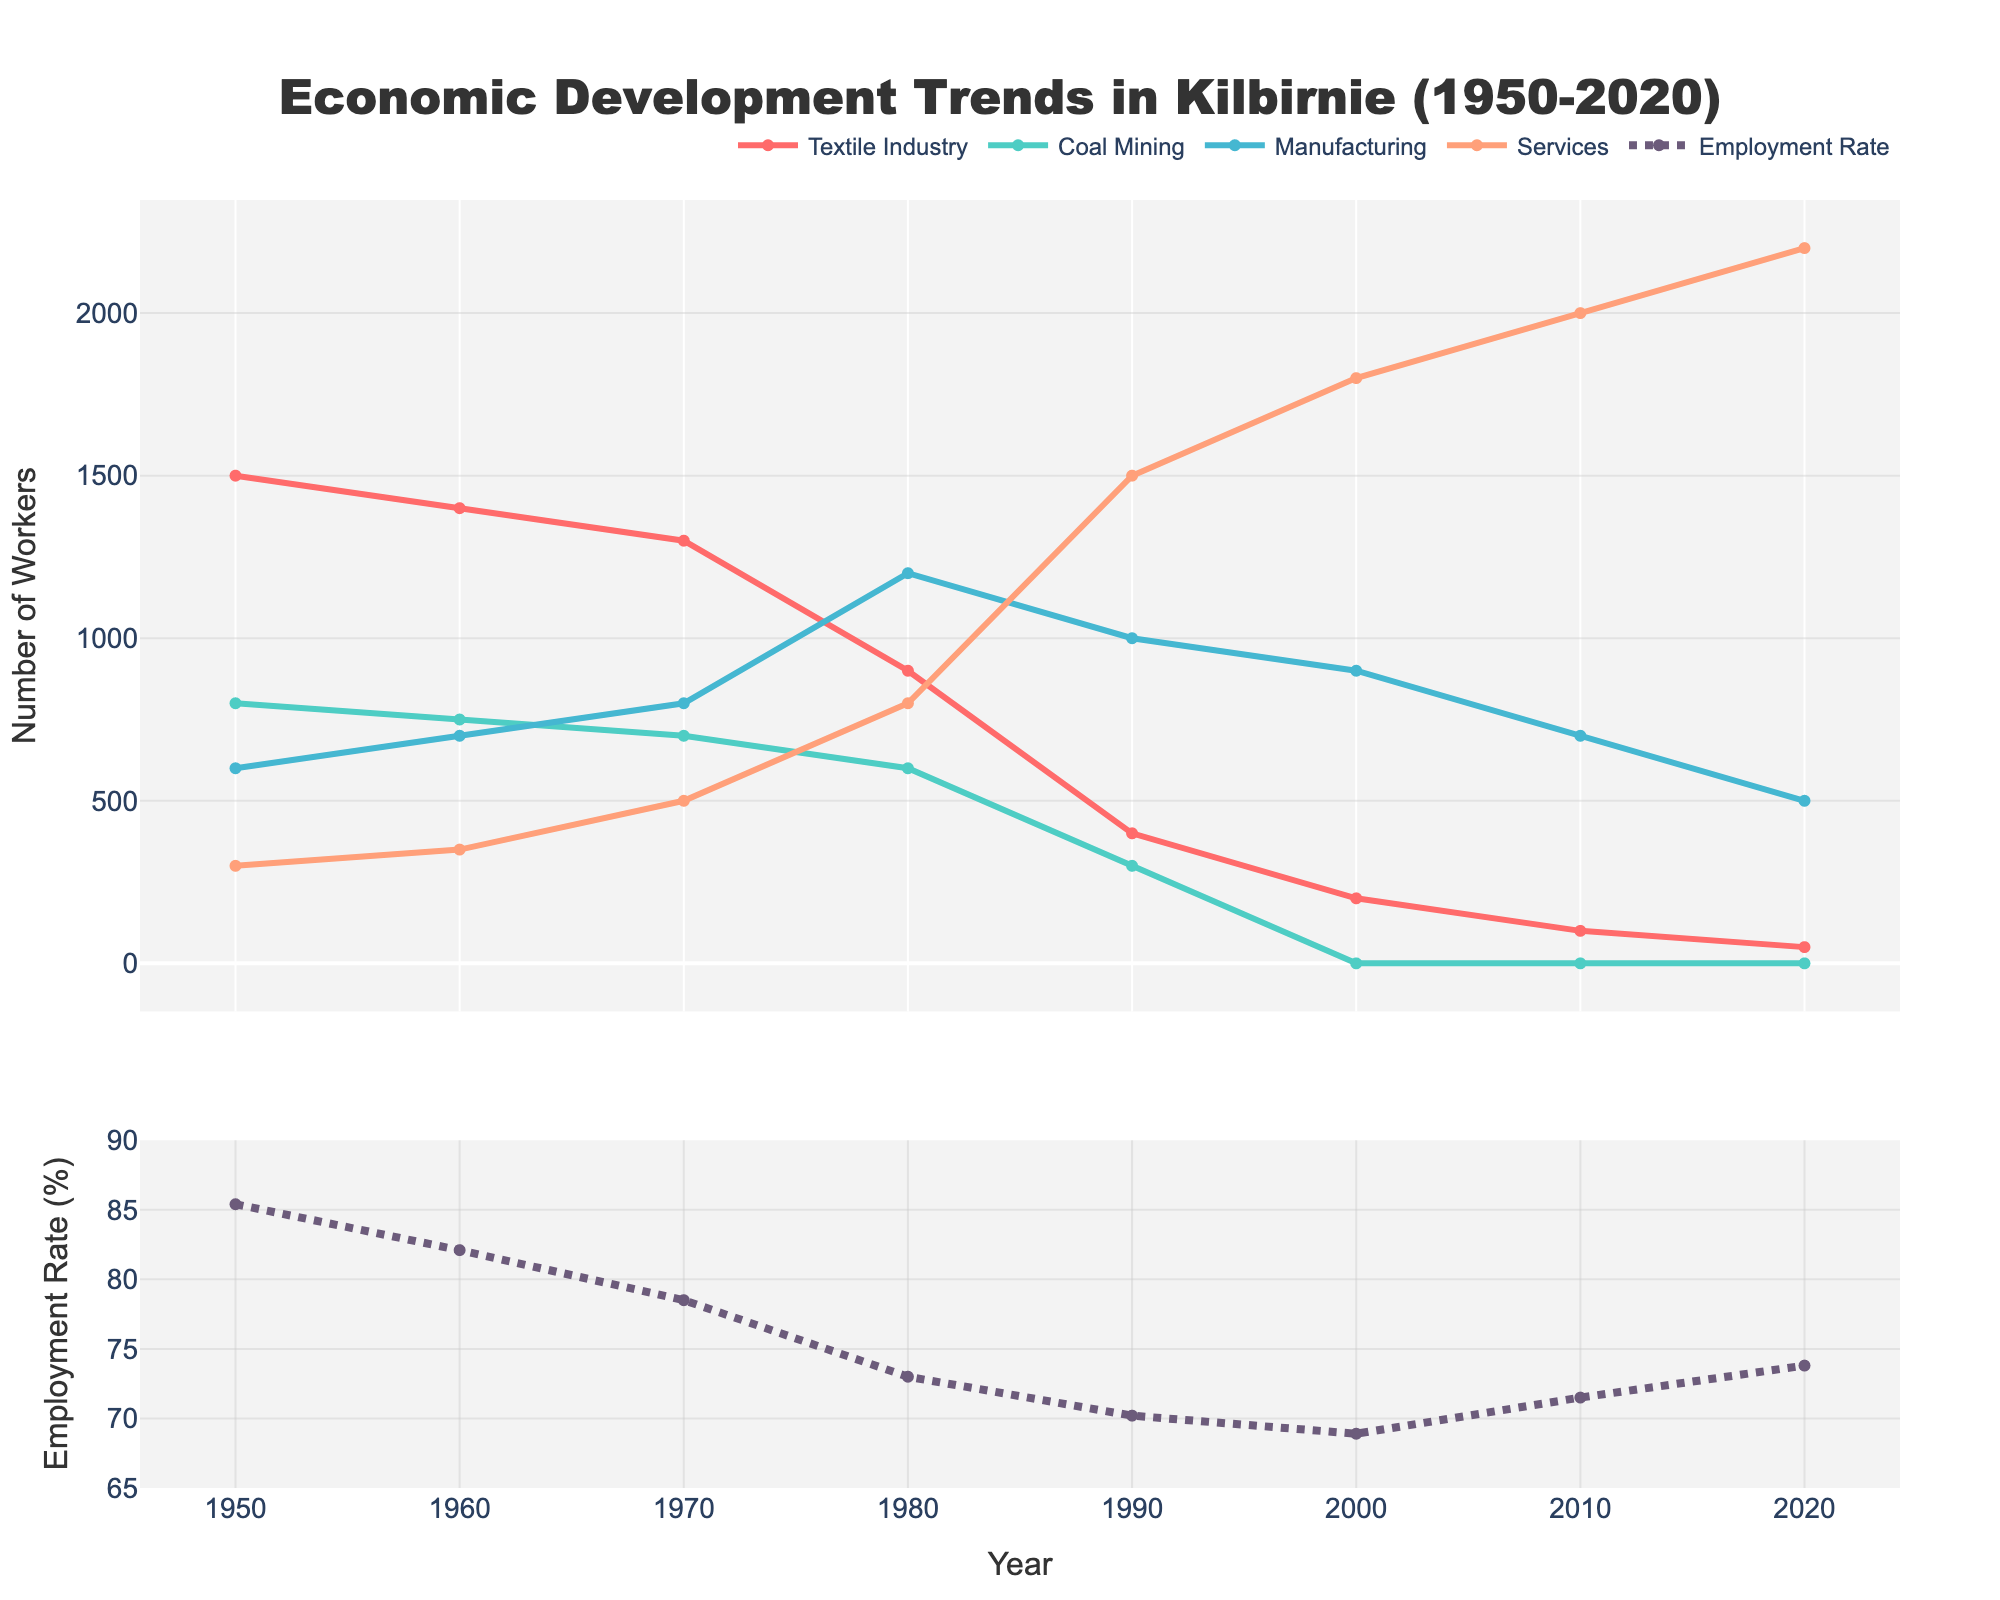When did the employment rate in Kilbirnie reach its lowest point? The employment rate reached its lowest point in 2000. This is observable in the second subplot where the employment rate dips to its lowest value.
Answer: 2000 How did the number of workers in the Textile Industry change from 1950 to 2020? In 1950, there were 1500 workers in the Textile Industry. By 2020, this number had declined to 50 workers. This drastic decrease is evident in the first subplot where the line corresponding to the Textile Industry steadily declines over the years.
Answer: Decreased by 1450 Which industry had the highest increase in the number of workers between 1950 and 2020? Comparing the initial and final values for each industry, the Services industry increased from 300 workers in 1950 to 2200 workers in 2020. This growth is the highest among all industries shown in the first subplot.
Answer: Services What is the overall trend of the employment rate from 1950 to 2020? The employment rate shows a declining trend from 1950 to 2000, followed by a slight increase from 2000 to 2020. This trend is clear from the dotted line in the second subplot, which drops from 85.4% in 1950 to a low of 68.9% in 2000 before rising to 73.8% by 2020.
Answer: Declining, then slight increase By how much did the number of workers in Coal Mining decrease between 1950 and 1990? The number of workers in Coal Mining decreased from 800 in 1950 to 300 in 1990, a difference of 500 workers. This decrement is visible in the first subplot where the coal mining line steadily falls over time.
Answer: 500 In which decade did the Manufacturing industry peak in terms of the number of workers? The Manufacturing industry peaked in 1980 with 1200 workers. This can be observed in the first subplot where the Manufacturing line reaches its highest point in 1980.
Answer: 1980 Which industry had no workers from 2000 onwards? The Coal Mining industry had no workers from 2000 onwards. This is revealed in the first subplot where the Coal Mining line drops to zero starting from the year 2000.
Answer: Coal Mining What was the employment rate in 1980 and how does it compare to the rate in 2020? The employment rate in 1980 was 73.0%. In 2020, it was 73.8%. The second subplot shows these rates, with 2020 having a slightly higher employment rate than 1980.
Answer: 1980: 73.0%, 2020: 73.8% Which industry had the most dramatic decline and during what period? The Textile Industry experienced the most dramatic decline from 1950 to 1990, going from 1500 workers to 400 workers. The first subplot indicates this sharp reduction over the four decades.
Answer: Textile Industry, 1950-1990 How does the number of workers in Services compare to Manufacturing in 2010? In 2010, there were 2000 workers in Services and 700 workers in Manufacturing. The first subplot shows that the Services sector had significantly more workers than the Manufacturing sector in that year.
Answer: Services: 2000, Manufacturing: 700 